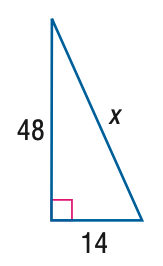Question: Use a Pythagorean Triple to find x.
Choices:
A. 50
B. 52
C. 54
D. 56
Answer with the letter. Answer: A 